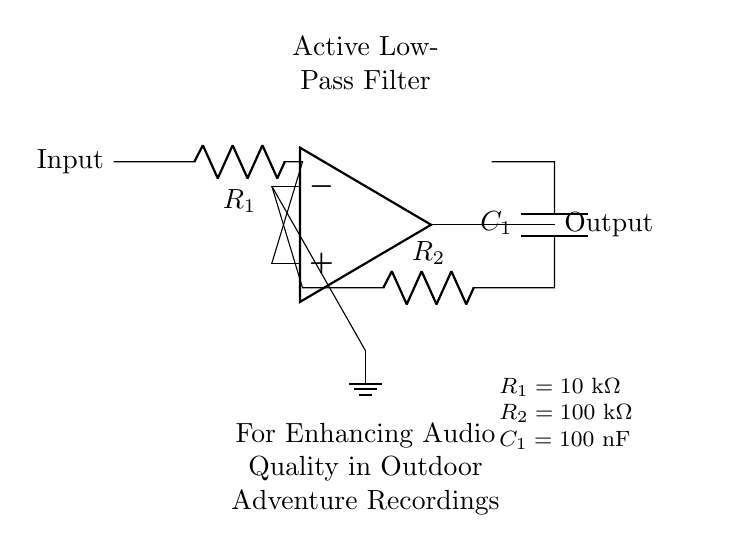What type of filter is implemented in this circuit? This circuit is labeled as an active low-pass filter, which is a type of electronic filter that allows signals with a frequency lower than a certain cutoff frequency to pass through and attenuates higher-frequency signals.
Answer: Active low-pass filter What is the value of R1 in this circuit? The value of R1 is given in the component values section of the diagram, which states that R1 equals 10 kOhm.
Answer: 10 kOhm How many resistors are used in this circuit? There are two resistors present in the circuit: R1 and R2, as illustrated in the diagram.
Answer: 2 resistors What is the capacitance of C1? The component values indicate that the capacitance of C1 is 100 nF (nanofarads), identified by the label next to the capacitor in the diagram.
Answer: 100 nF What is the purpose of the feedback network in this filter? The feedback network, consisting of R2 and C1, helps determine the frequency response of the filter, specifically its cutoff frequency and gain characteristics. This is crucial for filtering out unwanted high-frequency noise in audio applications.
Answer: To determine frequency response What affects the cutoff frequency in this active low-pass filter? The cutoff frequency of an active low-pass filter is primarily influenced by the values of R2 and C1, as these components are critical in the feedback network that sets the filter's response. The cutoff frequency can be calculated using the formula 1/(2πR2C1), where changes in R2 or C1 will impact the resulting cutoff frequency.
Answer: R2 and C1 